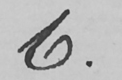What text is written in this handwritten line? 6 . 